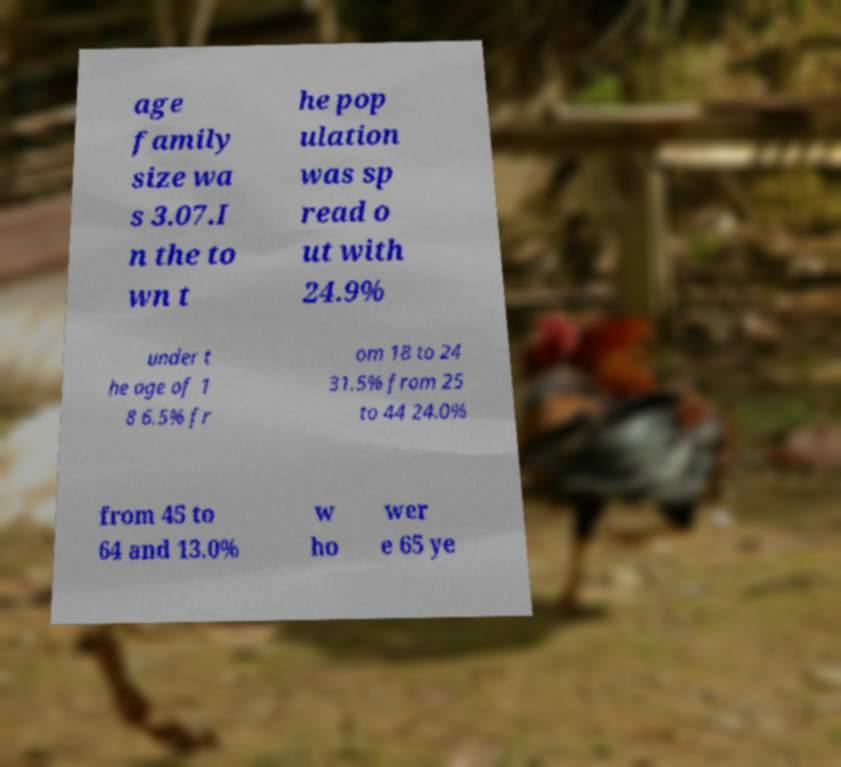For documentation purposes, I need the text within this image transcribed. Could you provide that? age family size wa s 3.07.I n the to wn t he pop ulation was sp read o ut with 24.9% under t he age of 1 8 6.5% fr om 18 to 24 31.5% from 25 to 44 24.0% from 45 to 64 and 13.0% w ho wer e 65 ye 